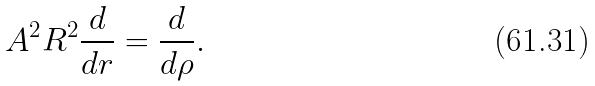Convert formula to latex. <formula><loc_0><loc_0><loc_500><loc_500>A ^ { 2 } R ^ { 2 } \frac { d } { d r } = \frac { d } { d \rho } .</formula> 